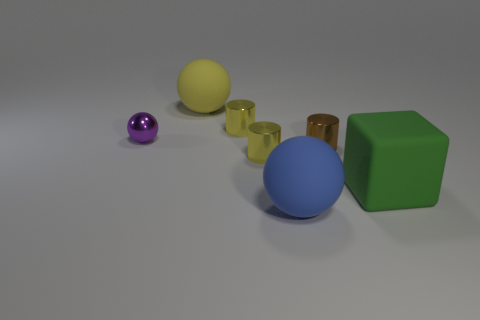Are there more large blue matte things than large purple blocks?
Offer a very short reply. Yes. There is a sphere that is behind the cube and on the right side of the small shiny ball; what size is it?
Your response must be concise. Large. Are there the same number of tiny yellow cylinders that are on the left side of the blue ball and large blocks?
Provide a succinct answer. No. Is the size of the yellow ball the same as the brown shiny thing?
Make the answer very short. No. The big thing that is in front of the small purple metal object and to the left of the block is what color?
Offer a terse response. Blue. What material is the yellow cylinder that is behind the yellow cylinder in front of the tiny purple ball made of?
Your response must be concise. Metal. There is a yellow matte thing that is the same shape as the small purple metal thing; what size is it?
Provide a succinct answer. Large. There is a large ball that is in front of the cube; is its color the same as the block?
Your response must be concise. No. Is the number of small things less than the number of yellow rubber things?
Keep it short and to the point. No. How many other objects are the same color as the small shiny ball?
Your answer should be compact. 0. 